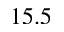Convert formula to latex. <formula><loc_0><loc_0><loc_500><loc_500>1 5 . 5</formula> 